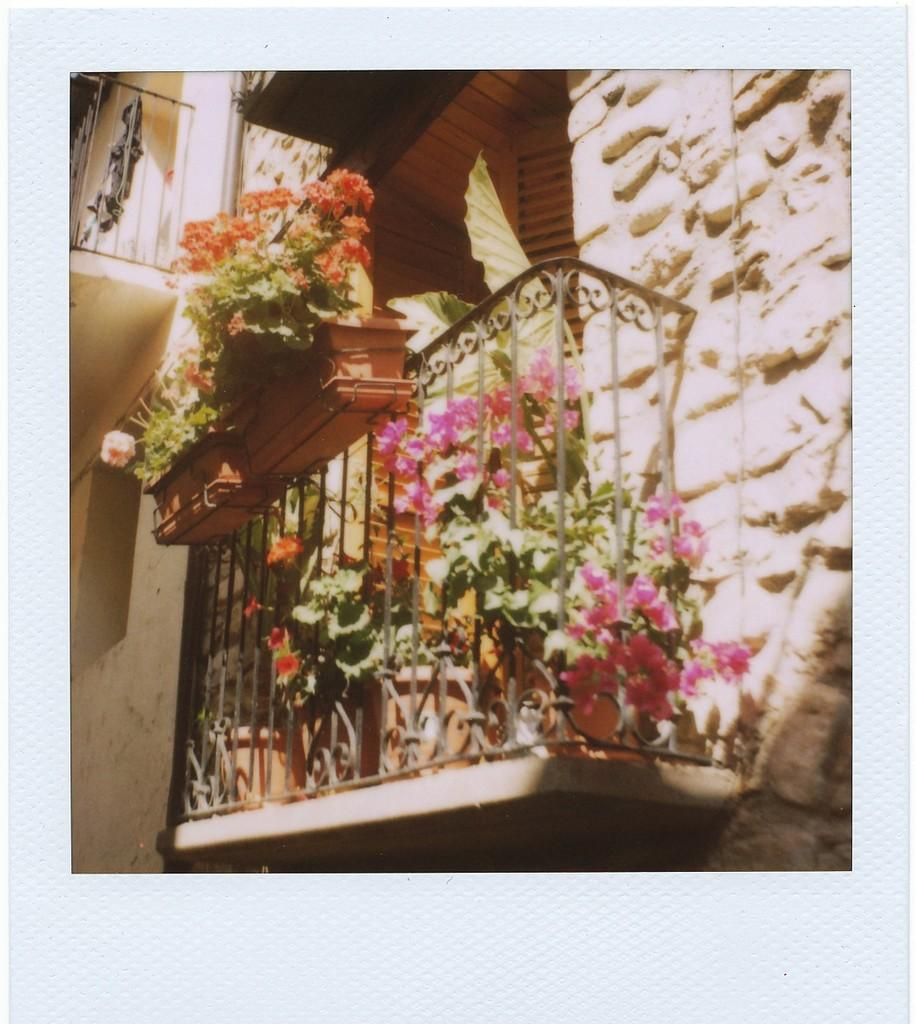What type of structure is visible in the image? There is a wall in the image. What can be seen attached to the wall? There are railings in the image. What type of vegetation is present in the image? There are plants in the image. What type of flowers can be seen in the image? There are flowers in the image. How does the boot help with digestion in the image? There is no boot present in the image, and therefore no such activity can be observed. 